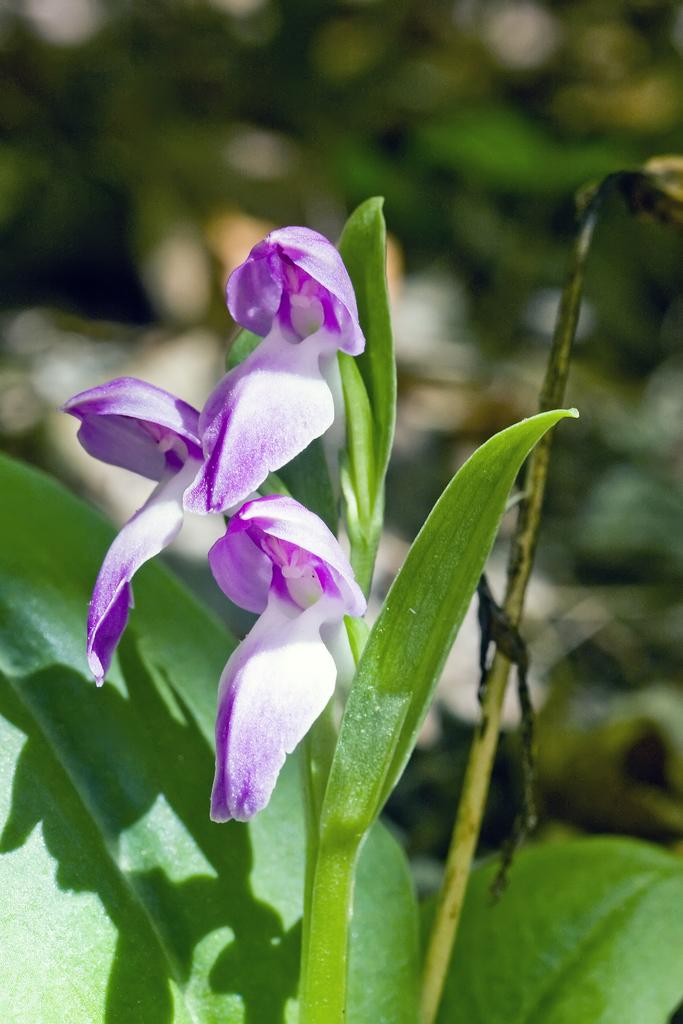What is present in the image? There is a plant in the image. What specific features can be observed on the plant? The plant has flowers, and the flowers are in violet and white colors. The leaves of the plant are also visible. How would you describe the background of the image? The background of the image is blurred. What type of prose is being recited by the son in the image? There is no son or any recitation of prose present in the image; it features a plant with flowers and blurred background. 